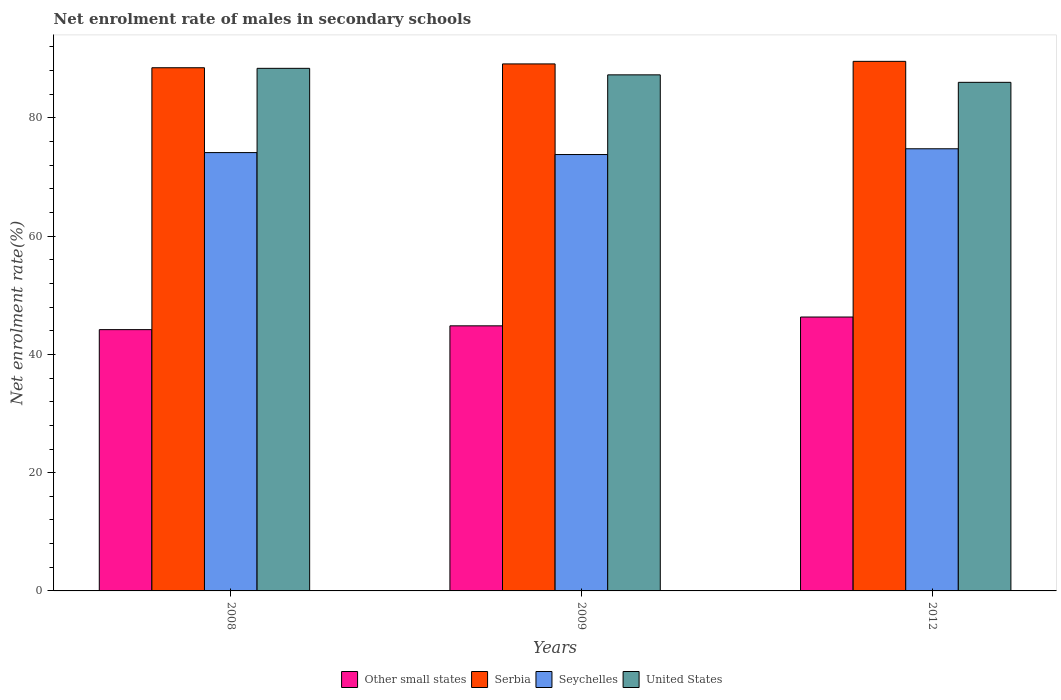How many groups of bars are there?
Keep it short and to the point. 3. How many bars are there on the 1st tick from the left?
Your answer should be very brief. 4. How many bars are there on the 3rd tick from the right?
Give a very brief answer. 4. In how many cases, is the number of bars for a given year not equal to the number of legend labels?
Give a very brief answer. 0. What is the net enrolment rate of males in secondary schools in Seychelles in 2012?
Make the answer very short. 74.77. Across all years, what is the maximum net enrolment rate of males in secondary schools in Seychelles?
Provide a succinct answer. 74.77. Across all years, what is the minimum net enrolment rate of males in secondary schools in United States?
Your answer should be compact. 86.01. In which year was the net enrolment rate of males in secondary schools in United States maximum?
Provide a short and direct response. 2008. What is the total net enrolment rate of males in secondary schools in United States in the graph?
Make the answer very short. 261.66. What is the difference between the net enrolment rate of males in secondary schools in Serbia in 2008 and that in 2009?
Provide a succinct answer. -0.65. What is the difference between the net enrolment rate of males in secondary schools in Other small states in 2008 and the net enrolment rate of males in secondary schools in United States in 2012?
Offer a very short reply. -41.82. What is the average net enrolment rate of males in secondary schools in Serbia per year?
Your response must be concise. 89.05. In the year 2008, what is the difference between the net enrolment rate of males in secondary schools in Serbia and net enrolment rate of males in secondary schools in Seychelles?
Ensure brevity in your answer.  14.35. In how many years, is the net enrolment rate of males in secondary schools in Serbia greater than 44 %?
Make the answer very short. 3. What is the ratio of the net enrolment rate of males in secondary schools in Seychelles in 2009 to that in 2012?
Give a very brief answer. 0.99. Is the net enrolment rate of males in secondary schools in Other small states in 2008 less than that in 2009?
Ensure brevity in your answer.  Yes. Is the difference between the net enrolment rate of males in secondary schools in Serbia in 2008 and 2012 greater than the difference between the net enrolment rate of males in secondary schools in Seychelles in 2008 and 2012?
Provide a succinct answer. No. What is the difference between the highest and the second highest net enrolment rate of males in secondary schools in Seychelles?
Give a very brief answer. 0.64. What is the difference between the highest and the lowest net enrolment rate of males in secondary schools in Serbia?
Provide a succinct answer. 1.08. What does the 2nd bar from the left in 2008 represents?
Your response must be concise. Serbia. What does the 2nd bar from the right in 2008 represents?
Ensure brevity in your answer.  Seychelles. How many years are there in the graph?
Offer a very short reply. 3. What is the difference between two consecutive major ticks on the Y-axis?
Your response must be concise. 20. Does the graph contain grids?
Your answer should be very brief. No. What is the title of the graph?
Offer a terse response. Net enrolment rate of males in secondary schools. What is the label or title of the Y-axis?
Provide a short and direct response. Net enrolment rate(%). What is the Net enrolment rate(%) in Other small states in 2008?
Ensure brevity in your answer.  44.19. What is the Net enrolment rate(%) in Serbia in 2008?
Offer a very short reply. 88.48. What is the Net enrolment rate(%) of Seychelles in 2008?
Offer a very short reply. 74.13. What is the Net enrolment rate(%) of United States in 2008?
Provide a succinct answer. 88.38. What is the Net enrolment rate(%) of Other small states in 2009?
Offer a terse response. 44.83. What is the Net enrolment rate(%) in Serbia in 2009?
Give a very brief answer. 89.12. What is the Net enrolment rate(%) in Seychelles in 2009?
Give a very brief answer. 73.8. What is the Net enrolment rate(%) of United States in 2009?
Offer a terse response. 87.27. What is the Net enrolment rate(%) of Other small states in 2012?
Provide a short and direct response. 46.32. What is the Net enrolment rate(%) in Serbia in 2012?
Your response must be concise. 89.56. What is the Net enrolment rate(%) of Seychelles in 2012?
Offer a very short reply. 74.77. What is the Net enrolment rate(%) of United States in 2012?
Your response must be concise. 86.01. Across all years, what is the maximum Net enrolment rate(%) in Other small states?
Keep it short and to the point. 46.32. Across all years, what is the maximum Net enrolment rate(%) of Serbia?
Offer a very short reply. 89.56. Across all years, what is the maximum Net enrolment rate(%) of Seychelles?
Give a very brief answer. 74.77. Across all years, what is the maximum Net enrolment rate(%) in United States?
Offer a very short reply. 88.38. Across all years, what is the minimum Net enrolment rate(%) in Other small states?
Offer a very short reply. 44.19. Across all years, what is the minimum Net enrolment rate(%) of Serbia?
Make the answer very short. 88.48. Across all years, what is the minimum Net enrolment rate(%) in Seychelles?
Make the answer very short. 73.8. Across all years, what is the minimum Net enrolment rate(%) in United States?
Provide a short and direct response. 86.01. What is the total Net enrolment rate(%) of Other small states in the graph?
Ensure brevity in your answer.  135.34. What is the total Net enrolment rate(%) of Serbia in the graph?
Keep it short and to the point. 267.16. What is the total Net enrolment rate(%) in Seychelles in the graph?
Give a very brief answer. 222.7. What is the total Net enrolment rate(%) in United States in the graph?
Ensure brevity in your answer.  261.66. What is the difference between the Net enrolment rate(%) of Other small states in 2008 and that in 2009?
Your answer should be compact. -0.64. What is the difference between the Net enrolment rate(%) in Serbia in 2008 and that in 2009?
Your response must be concise. -0.65. What is the difference between the Net enrolment rate(%) in Seychelles in 2008 and that in 2009?
Provide a short and direct response. 0.33. What is the difference between the Net enrolment rate(%) of United States in 2008 and that in 2009?
Provide a succinct answer. 1.1. What is the difference between the Net enrolment rate(%) of Other small states in 2008 and that in 2012?
Provide a short and direct response. -2.13. What is the difference between the Net enrolment rate(%) of Serbia in 2008 and that in 2012?
Your answer should be very brief. -1.08. What is the difference between the Net enrolment rate(%) in Seychelles in 2008 and that in 2012?
Give a very brief answer. -0.64. What is the difference between the Net enrolment rate(%) of United States in 2008 and that in 2012?
Provide a short and direct response. 2.37. What is the difference between the Net enrolment rate(%) of Other small states in 2009 and that in 2012?
Keep it short and to the point. -1.49. What is the difference between the Net enrolment rate(%) of Serbia in 2009 and that in 2012?
Your response must be concise. -0.43. What is the difference between the Net enrolment rate(%) of Seychelles in 2009 and that in 2012?
Provide a short and direct response. -0.97. What is the difference between the Net enrolment rate(%) in United States in 2009 and that in 2012?
Provide a succinct answer. 1.26. What is the difference between the Net enrolment rate(%) of Other small states in 2008 and the Net enrolment rate(%) of Serbia in 2009?
Your response must be concise. -44.94. What is the difference between the Net enrolment rate(%) of Other small states in 2008 and the Net enrolment rate(%) of Seychelles in 2009?
Your answer should be compact. -29.61. What is the difference between the Net enrolment rate(%) in Other small states in 2008 and the Net enrolment rate(%) in United States in 2009?
Your response must be concise. -43.09. What is the difference between the Net enrolment rate(%) of Serbia in 2008 and the Net enrolment rate(%) of Seychelles in 2009?
Provide a succinct answer. 14.68. What is the difference between the Net enrolment rate(%) of Serbia in 2008 and the Net enrolment rate(%) of United States in 2009?
Offer a terse response. 1.2. What is the difference between the Net enrolment rate(%) in Seychelles in 2008 and the Net enrolment rate(%) in United States in 2009?
Offer a terse response. -13.15. What is the difference between the Net enrolment rate(%) of Other small states in 2008 and the Net enrolment rate(%) of Serbia in 2012?
Offer a very short reply. -45.37. What is the difference between the Net enrolment rate(%) of Other small states in 2008 and the Net enrolment rate(%) of Seychelles in 2012?
Offer a very short reply. -30.59. What is the difference between the Net enrolment rate(%) in Other small states in 2008 and the Net enrolment rate(%) in United States in 2012?
Your response must be concise. -41.82. What is the difference between the Net enrolment rate(%) in Serbia in 2008 and the Net enrolment rate(%) in Seychelles in 2012?
Make the answer very short. 13.7. What is the difference between the Net enrolment rate(%) of Serbia in 2008 and the Net enrolment rate(%) of United States in 2012?
Offer a very short reply. 2.47. What is the difference between the Net enrolment rate(%) of Seychelles in 2008 and the Net enrolment rate(%) of United States in 2012?
Offer a very short reply. -11.88. What is the difference between the Net enrolment rate(%) in Other small states in 2009 and the Net enrolment rate(%) in Serbia in 2012?
Offer a terse response. -44.73. What is the difference between the Net enrolment rate(%) of Other small states in 2009 and the Net enrolment rate(%) of Seychelles in 2012?
Give a very brief answer. -29.94. What is the difference between the Net enrolment rate(%) in Other small states in 2009 and the Net enrolment rate(%) in United States in 2012?
Your answer should be very brief. -41.18. What is the difference between the Net enrolment rate(%) of Serbia in 2009 and the Net enrolment rate(%) of Seychelles in 2012?
Give a very brief answer. 14.35. What is the difference between the Net enrolment rate(%) of Serbia in 2009 and the Net enrolment rate(%) of United States in 2012?
Offer a terse response. 3.11. What is the difference between the Net enrolment rate(%) of Seychelles in 2009 and the Net enrolment rate(%) of United States in 2012?
Ensure brevity in your answer.  -12.21. What is the average Net enrolment rate(%) in Other small states per year?
Ensure brevity in your answer.  45.11. What is the average Net enrolment rate(%) in Serbia per year?
Keep it short and to the point. 89.05. What is the average Net enrolment rate(%) in Seychelles per year?
Your answer should be very brief. 74.23. What is the average Net enrolment rate(%) in United States per year?
Give a very brief answer. 87.22. In the year 2008, what is the difference between the Net enrolment rate(%) of Other small states and Net enrolment rate(%) of Serbia?
Give a very brief answer. -44.29. In the year 2008, what is the difference between the Net enrolment rate(%) in Other small states and Net enrolment rate(%) in Seychelles?
Your answer should be very brief. -29.94. In the year 2008, what is the difference between the Net enrolment rate(%) of Other small states and Net enrolment rate(%) of United States?
Give a very brief answer. -44.19. In the year 2008, what is the difference between the Net enrolment rate(%) of Serbia and Net enrolment rate(%) of Seychelles?
Your answer should be very brief. 14.35. In the year 2008, what is the difference between the Net enrolment rate(%) of Serbia and Net enrolment rate(%) of United States?
Your answer should be very brief. 0.1. In the year 2008, what is the difference between the Net enrolment rate(%) of Seychelles and Net enrolment rate(%) of United States?
Keep it short and to the point. -14.25. In the year 2009, what is the difference between the Net enrolment rate(%) of Other small states and Net enrolment rate(%) of Serbia?
Provide a short and direct response. -44.29. In the year 2009, what is the difference between the Net enrolment rate(%) in Other small states and Net enrolment rate(%) in Seychelles?
Provide a succinct answer. -28.97. In the year 2009, what is the difference between the Net enrolment rate(%) of Other small states and Net enrolment rate(%) of United States?
Ensure brevity in your answer.  -42.44. In the year 2009, what is the difference between the Net enrolment rate(%) of Serbia and Net enrolment rate(%) of Seychelles?
Ensure brevity in your answer.  15.33. In the year 2009, what is the difference between the Net enrolment rate(%) of Serbia and Net enrolment rate(%) of United States?
Ensure brevity in your answer.  1.85. In the year 2009, what is the difference between the Net enrolment rate(%) in Seychelles and Net enrolment rate(%) in United States?
Offer a terse response. -13.48. In the year 2012, what is the difference between the Net enrolment rate(%) in Other small states and Net enrolment rate(%) in Serbia?
Offer a very short reply. -43.24. In the year 2012, what is the difference between the Net enrolment rate(%) of Other small states and Net enrolment rate(%) of Seychelles?
Offer a very short reply. -28.45. In the year 2012, what is the difference between the Net enrolment rate(%) of Other small states and Net enrolment rate(%) of United States?
Make the answer very short. -39.69. In the year 2012, what is the difference between the Net enrolment rate(%) of Serbia and Net enrolment rate(%) of Seychelles?
Offer a very short reply. 14.78. In the year 2012, what is the difference between the Net enrolment rate(%) of Serbia and Net enrolment rate(%) of United States?
Your response must be concise. 3.55. In the year 2012, what is the difference between the Net enrolment rate(%) of Seychelles and Net enrolment rate(%) of United States?
Offer a very short reply. -11.24. What is the ratio of the Net enrolment rate(%) of Other small states in 2008 to that in 2009?
Your answer should be compact. 0.99. What is the ratio of the Net enrolment rate(%) of United States in 2008 to that in 2009?
Provide a short and direct response. 1.01. What is the ratio of the Net enrolment rate(%) in Other small states in 2008 to that in 2012?
Give a very brief answer. 0.95. What is the ratio of the Net enrolment rate(%) of Serbia in 2008 to that in 2012?
Provide a short and direct response. 0.99. What is the ratio of the Net enrolment rate(%) in Seychelles in 2008 to that in 2012?
Offer a terse response. 0.99. What is the ratio of the Net enrolment rate(%) of United States in 2008 to that in 2012?
Offer a very short reply. 1.03. What is the ratio of the Net enrolment rate(%) of Other small states in 2009 to that in 2012?
Ensure brevity in your answer.  0.97. What is the ratio of the Net enrolment rate(%) in Seychelles in 2009 to that in 2012?
Keep it short and to the point. 0.99. What is the ratio of the Net enrolment rate(%) in United States in 2009 to that in 2012?
Keep it short and to the point. 1.01. What is the difference between the highest and the second highest Net enrolment rate(%) of Other small states?
Offer a very short reply. 1.49. What is the difference between the highest and the second highest Net enrolment rate(%) of Serbia?
Keep it short and to the point. 0.43. What is the difference between the highest and the second highest Net enrolment rate(%) in Seychelles?
Ensure brevity in your answer.  0.64. What is the difference between the highest and the second highest Net enrolment rate(%) of United States?
Your answer should be very brief. 1.1. What is the difference between the highest and the lowest Net enrolment rate(%) in Other small states?
Your response must be concise. 2.13. What is the difference between the highest and the lowest Net enrolment rate(%) of Serbia?
Ensure brevity in your answer.  1.08. What is the difference between the highest and the lowest Net enrolment rate(%) of Seychelles?
Offer a very short reply. 0.97. What is the difference between the highest and the lowest Net enrolment rate(%) of United States?
Provide a short and direct response. 2.37. 